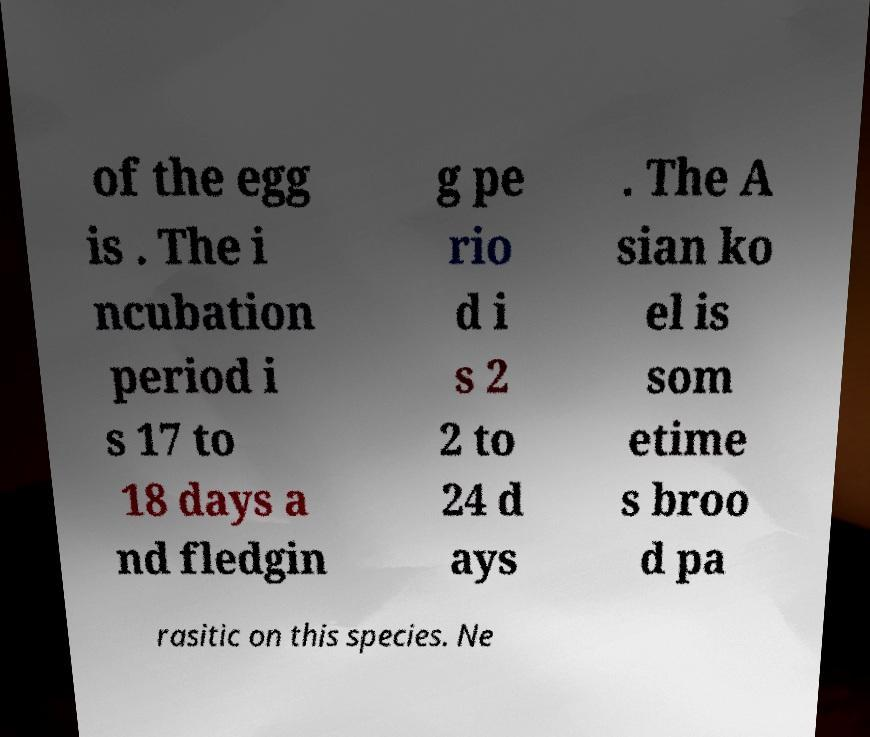What messages or text are displayed in this image? I need them in a readable, typed format. of the egg is . The i ncubation period i s 17 to 18 days a nd fledgin g pe rio d i s 2 2 to 24 d ays . The A sian ko el is som etime s broo d pa rasitic on this species. Ne 